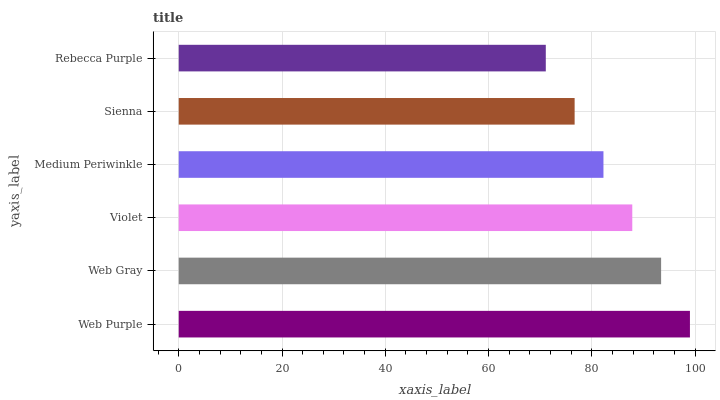Is Rebecca Purple the minimum?
Answer yes or no. Yes. Is Web Purple the maximum?
Answer yes or no. Yes. Is Web Gray the minimum?
Answer yes or no. No. Is Web Gray the maximum?
Answer yes or no. No. Is Web Purple greater than Web Gray?
Answer yes or no. Yes. Is Web Gray less than Web Purple?
Answer yes or no. Yes. Is Web Gray greater than Web Purple?
Answer yes or no. No. Is Web Purple less than Web Gray?
Answer yes or no. No. Is Violet the high median?
Answer yes or no. Yes. Is Medium Periwinkle the low median?
Answer yes or no. Yes. Is Web Gray the high median?
Answer yes or no. No. Is Web Purple the low median?
Answer yes or no. No. 